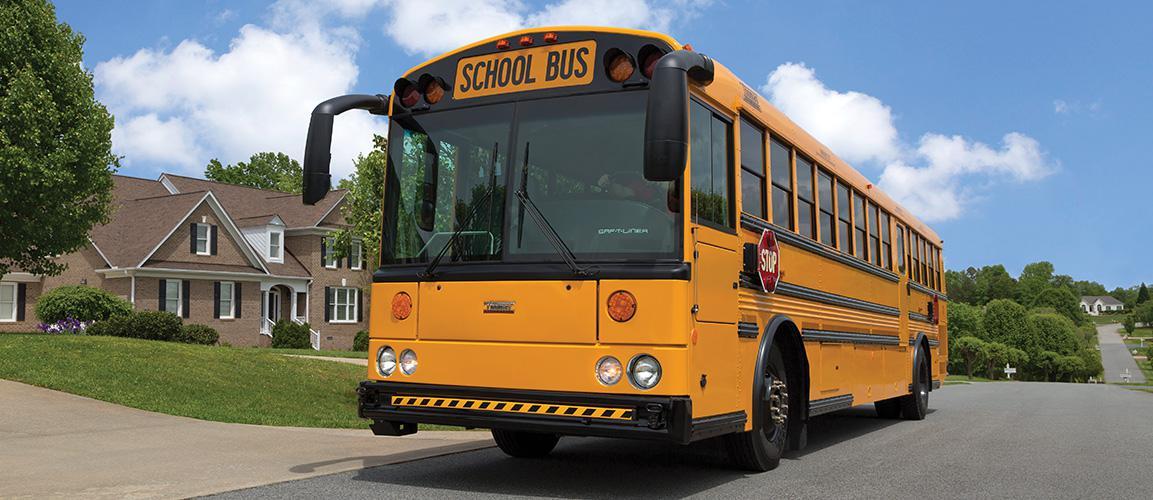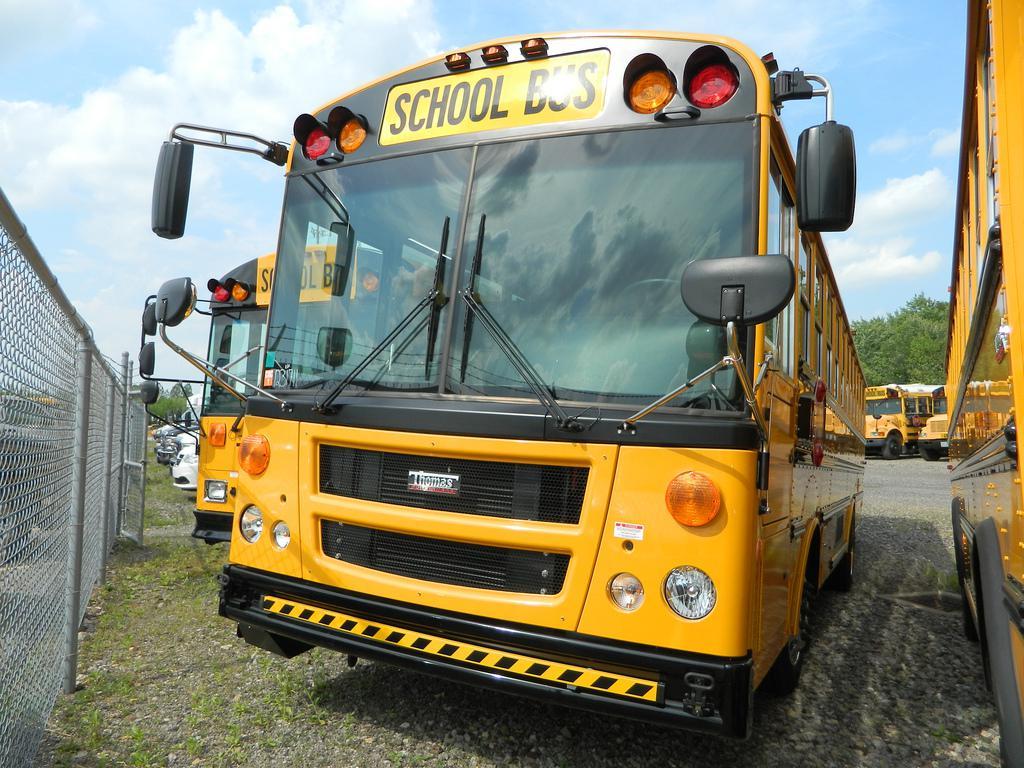The first image is the image on the left, the second image is the image on the right. Analyze the images presented: Is the assertion "In at least one image there is a single bus with a closed front grill facing slightly right" valid? Answer yes or no. No. The first image is the image on the left, the second image is the image on the right. Considering the images on both sides, is "Each image shows a flat-fronted bus with a black-and-yellow striped line on its black bumper, and the buses on the left and right face the same direction." valid? Answer yes or no. Yes. 